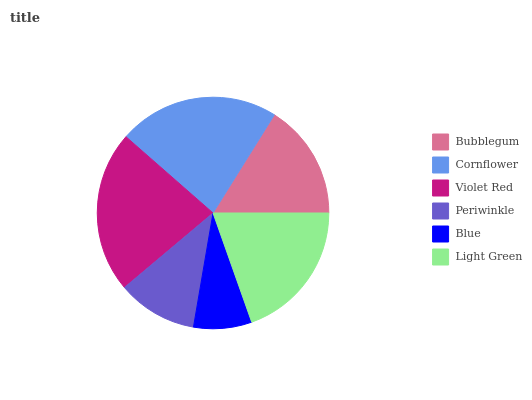Is Blue the minimum?
Answer yes or no. Yes. Is Violet Red the maximum?
Answer yes or no. Yes. Is Cornflower the minimum?
Answer yes or no. No. Is Cornflower the maximum?
Answer yes or no. No. Is Cornflower greater than Bubblegum?
Answer yes or no. Yes. Is Bubblegum less than Cornflower?
Answer yes or no. Yes. Is Bubblegum greater than Cornflower?
Answer yes or no. No. Is Cornflower less than Bubblegum?
Answer yes or no. No. Is Light Green the high median?
Answer yes or no. Yes. Is Bubblegum the low median?
Answer yes or no. Yes. Is Violet Red the high median?
Answer yes or no. No. Is Violet Red the low median?
Answer yes or no. No. 